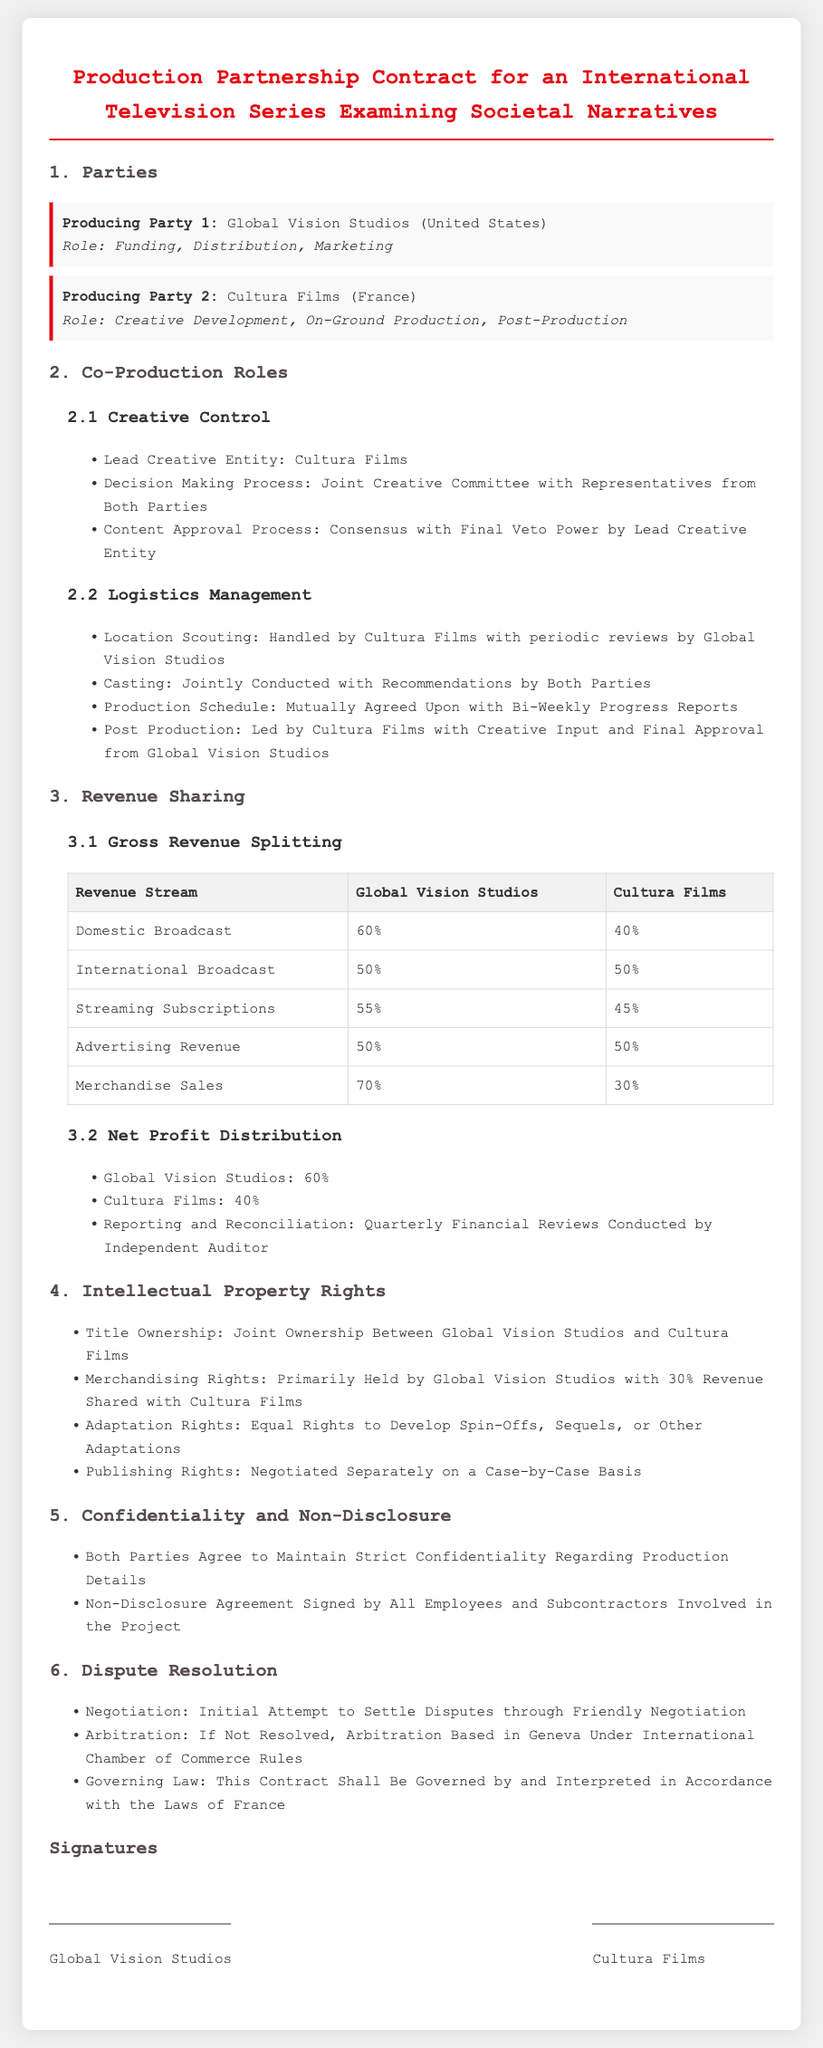what is the name of Producing Party 1? The name of Producing Party 1 as stated in the document is Global Vision Studios.
Answer: Global Vision Studios what role does Cultura Films have? Cultura Films is involved in Creative Development, On-Ground Production, and Post-Production.
Answer: Creative Development, On-Ground Production, Post-Production who has the lead creative entity? The lead creative entity, as specified, is Cultura Films.
Answer: Cultura Films what percentage of domestic broadcast revenue does Global Vision Studios receive? Global Vision Studios receives 60% of the domestic broadcast revenue, as mentioned in the revenue sharing section.
Answer: 60% how are disputes resolved according to the contract? Disputes are to be settled through friendly negotiation followed by arbitration if not resolved.
Answer: Friendly negotiation, arbitration what is the distribution split for merchandise sales? The document states that Global Vision Studios gets 70% of merchandise sales, while Cultura Films receives 30%.
Answer: 70%, 30% who will have final approval in post-production? Final approval in post-production is granted to Global Vision Studios, according to the document.
Answer: Global Vision Studios what is the governing law for the contract? The governing law stated in the document is the laws of France.
Answer: Laws of France 